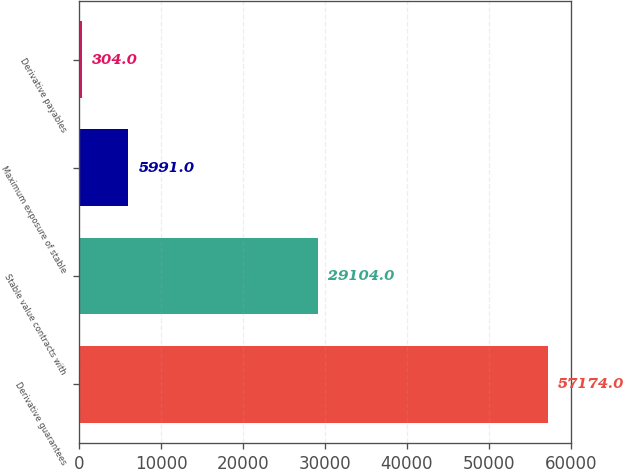<chart> <loc_0><loc_0><loc_500><loc_500><bar_chart><fcel>Derivative guarantees<fcel>Stable value contracts with<fcel>Maximum exposure of stable<fcel>Derivative payables<nl><fcel>57174<fcel>29104<fcel>5991<fcel>304<nl></chart> 